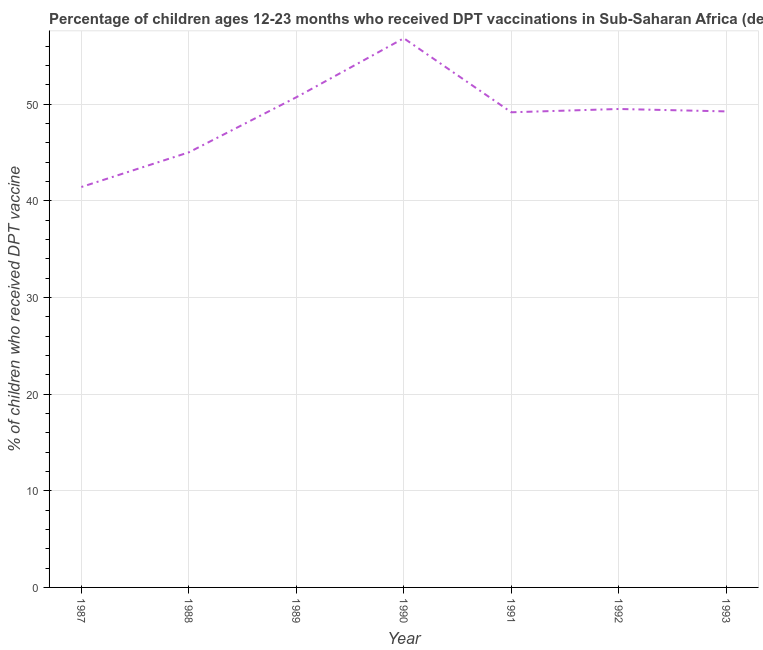What is the percentage of children who received dpt vaccine in 1992?
Your response must be concise. 49.51. Across all years, what is the maximum percentage of children who received dpt vaccine?
Ensure brevity in your answer.  56.83. Across all years, what is the minimum percentage of children who received dpt vaccine?
Make the answer very short. 41.44. In which year was the percentage of children who received dpt vaccine minimum?
Give a very brief answer. 1987. What is the sum of the percentage of children who received dpt vaccine?
Make the answer very short. 341.99. What is the difference between the percentage of children who received dpt vaccine in 1988 and 1990?
Offer a very short reply. -11.81. What is the average percentage of children who received dpt vaccine per year?
Make the answer very short. 48.86. What is the median percentage of children who received dpt vaccine?
Your answer should be very brief. 49.27. In how many years, is the percentage of children who received dpt vaccine greater than 12 %?
Ensure brevity in your answer.  7. Do a majority of the years between 1989 and 1988 (inclusive) have percentage of children who received dpt vaccine greater than 4 %?
Provide a short and direct response. No. What is the ratio of the percentage of children who received dpt vaccine in 1987 to that in 1990?
Provide a succinct answer. 0.73. Is the percentage of children who received dpt vaccine in 1988 less than that in 1990?
Keep it short and to the point. Yes. Is the difference between the percentage of children who received dpt vaccine in 1991 and 1993 greater than the difference between any two years?
Offer a very short reply. No. What is the difference between the highest and the second highest percentage of children who received dpt vaccine?
Offer a terse response. 6.11. Is the sum of the percentage of children who received dpt vaccine in 1987 and 1990 greater than the maximum percentage of children who received dpt vaccine across all years?
Your answer should be very brief. Yes. What is the difference between the highest and the lowest percentage of children who received dpt vaccine?
Provide a short and direct response. 15.39. In how many years, is the percentage of children who received dpt vaccine greater than the average percentage of children who received dpt vaccine taken over all years?
Give a very brief answer. 5. How many lines are there?
Provide a succinct answer. 1. How many years are there in the graph?
Provide a short and direct response. 7. Are the values on the major ticks of Y-axis written in scientific E-notation?
Your answer should be very brief. No. Does the graph contain grids?
Your answer should be very brief. Yes. What is the title of the graph?
Your answer should be compact. Percentage of children ages 12-23 months who received DPT vaccinations in Sub-Saharan Africa (developing only). What is the label or title of the X-axis?
Your answer should be very brief. Year. What is the label or title of the Y-axis?
Your answer should be very brief. % of children who received DPT vaccine. What is the % of children who received DPT vaccine in 1987?
Provide a short and direct response. 41.44. What is the % of children who received DPT vaccine in 1988?
Provide a succinct answer. 45.03. What is the % of children who received DPT vaccine in 1989?
Your response must be concise. 50.73. What is the % of children who received DPT vaccine in 1990?
Your response must be concise. 56.83. What is the % of children who received DPT vaccine in 1991?
Give a very brief answer. 49.17. What is the % of children who received DPT vaccine of 1992?
Make the answer very short. 49.51. What is the % of children who received DPT vaccine in 1993?
Provide a succinct answer. 49.27. What is the difference between the % of children who received DPT vaccine in 1987 and 1988?
Give a very brief answer. -3.59. What is the difference between the % of children who received DPT vaccine in 1987 and 1989?
Make the answer very short. -9.29. What is the difference between the % of children who received DPT vaccine in 1987 and 1990?
Make the answer very short. -15.39. What is the difference between the % of children who received DPT vaccine in 1987 and 1991?
Provide a short and direct response. -7.73. What is the difference between the % of children who received DPT vaccine in 1987 and 1992?
Give a very brief answer. -8.07. What is the difference between the % of children who received DPT vaccine in 1987 and 1993?
Provide a short and direct response. -7.82. What is the difference between the % of children who received DPT vaccine in 1988 and 1989?
Give a very brief answer. -5.7. What is the difference between the % of children who received DPT vaccine in 1988 and 1990?
Make the answer very short. -11.81. What is the difference between the % of children who received DPT vaccine in 1988 and 1991?
Give a very brief answer. -4.14. What is the difference between the % of children who received DPT vaccine in 1988 and 1992?
Provide a short and direct response. -4.49. What is the difference between the % of children who received DPT vaccine in 1988 and 1993?
Provide a short and direct response. -4.24. What is the difference between the % of children who received DPT vaccine in 1989 and 1990?
Your answer should be very brief. -6.11. What is the difference between the % of children who received DPT vaccine in 1989 and 1991?
Make the answer very short. 1.55. What is the difference between the % of children who received DPT vaccine in 1989 and 1992?
Provide a succinct answer. 1.21. What is the difference between the % of children who received DPT vaccine in 1989 and 1993?
Ensure brevity in your answer.  1.46. What is the difference between the % of children who received DPT vaccine in 1990 and 1991?
Give a very brief answer. 7.66. What is the difference between the % of children who received DPT vaccine in 1990 and 1992?
Keep it short and to the point. 7.32. What is the difference between the % of children who received DPT vaccine in 1990 and 1993?
Your answer should be compact. 7.57. What is the difference between the % of children who received DPT vaccine in 1991 and 1992?
Ensure brevity in your answer.  -0.34. What is the difference between the % of children who received DPT vaccine in 1991 and 1993?
Your answer should be compact. -0.09. What is the difference between the % of children who received DPT vaccine in 1992 and 1993?
Your response must be concise. 0.25. What is the ratio of the % of children who received DPT vaccine in 1987 to that in 1989?
Provide a succinct answer. 0.82. What is the ratio of the % of children who received DPT vaccine in 1987 to that in 1990?
Keep it short and to the point. 0.73. What is the ratio of the % of children who received DPT vaccine in 1987 to that in 1991?
Make the answer very short. 0.84. What is the ratio of the % of children who received DPT vaccine in 1987 to that in 1992?
Your answer should be very brief. 0.84. What is the ratio of the % of children who received DPT vaccine in 1987 to that in 1993?
Offer a terse response. 0.84. What is the ratio of the % of children who received DPT vaccine in 1988 to that in 1989?
Provide a short and direct response. 0.89. What is the ratio of the % of children who received DPT vaccine in 1988 to that in 1990?
Make the answer very short. 0.79. What is the ratio of the % of children who received DPT vaccine in 1988 to that in 1991?
Provide a short and direct response. 0.92. What is the ratio of the % of children who received DPT vaccine in 1988 to that in 1992?
Make the answer very short. 0.91. What is the ratio of the % of children who received DPT vaccine in 1988 to that in 1993?
Offer a terse response. 0.91. What is the ratio of the % of children who received DPT vaccine in 1989 to that in 1990?
Provide a succinct answer. 0.89. What is the ratio of the % of children who received DPT vaccine in 1989 to that in 1991?
Your answer should be very brief. 1.03. What is the ratio of the % of children who received DPT vaccine in 1989 to that in 1992?
Your response must be concise. 1.02. What is the ratio of the % of children who received DPT vaccine in 1989 to that in 1993?
Offer a terse response. 1.03. What is the ratio of the % of children who received DPT vaccine in 1990 to that in 1991?
Your answer should be very brief. 1.16. What is the ratio of the % of children who received DPT vaccine in 1990 to that in 1992?
Provide a succinct answer. 1.15. What is the ratio of the % of children who received DPT vaccine in 1990 to that in 1993?
Provide a short and direct response. 1.15. What is the ratio of the % of children who received DPT vaccine in 1992 to that in 1993?
Offer a terse response. 1. 